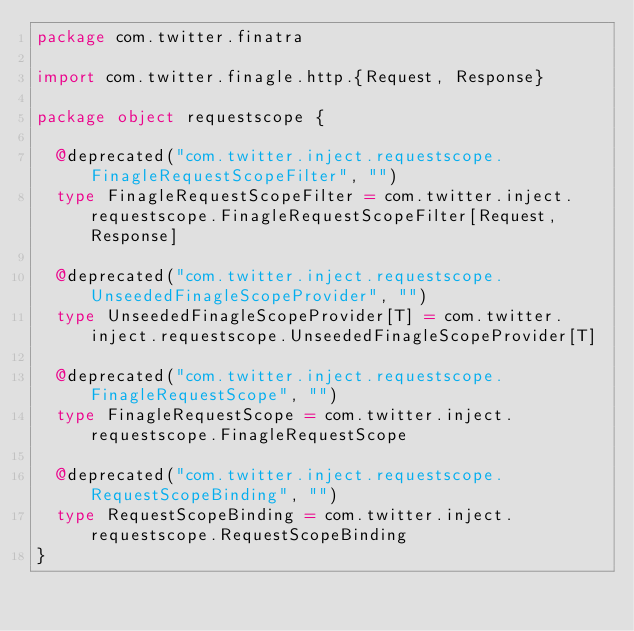Convert code to text. <code><loc_0><loc_0><loc_500><loc_500><_Scala_>package com.twitter.finatra

import com.twitter.finagle.http.{Request, Response}

package object requestscope {

  @deprecated("com.twitter.inject.requestscope.FinagleRequestScopeFilter", "")
  type FinagleRequestScopeFilter = com.twitter.inject.requestscope.FinagleRequestScopeFilter[Request, Response]

  @deprecated("com.twitter.inject.requestscope.UnseededFinagleScopeProvider", "")
  type UnseededFinagleScopeProvider[T] = com.twitter.inject.requestscope.UnseededFinagleScopeProvider[T]

  @deprecated("com.twitter.inject.requestscope.FinagleRequestScope", "")
  type FinagleRequestScope = com.twitter.inject.requestscope.FinagleRequestScope

  @deprecated("com.twitter.inject.requestscope.RequestScopeBinding", "")
  type RequestScopeBinding = com.twitter.inject.requestscope.RequestScopeBinding
}
</code> 